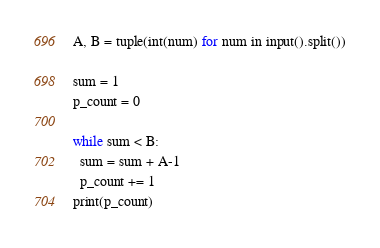Convert code to text. <code><loc_0><loc_0><loc_500><loc_500><_Python_>A, B = tuple(int(num) for num in input().split())

sum = 1
p_count = 0

while sum < B:
  sum = sum + A-1
  p_count += 1
print(p_count)</code> 